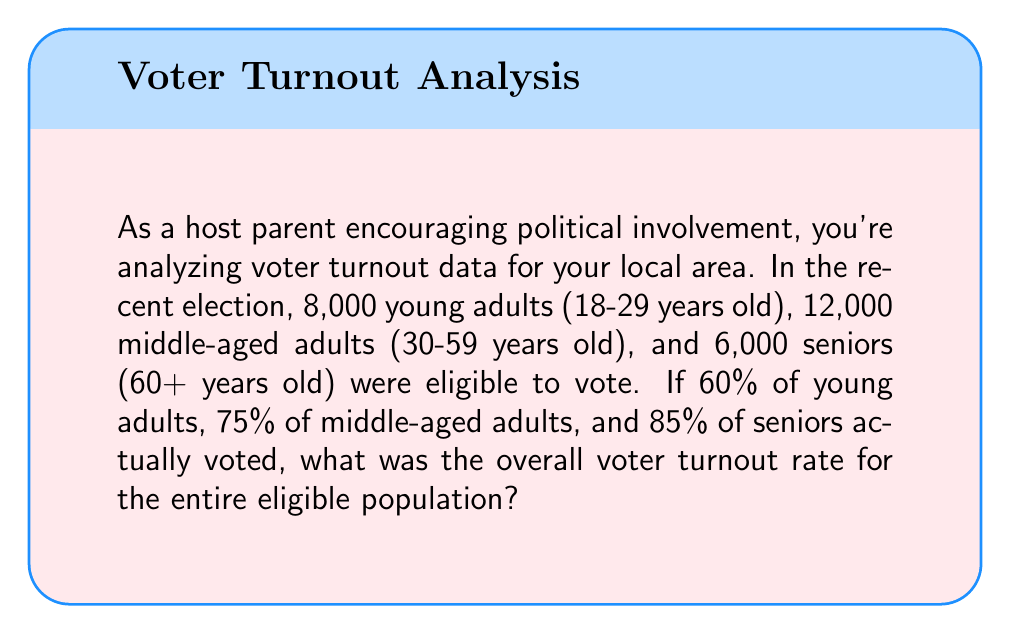Provide a solution to this math problem. Let's approach this step-by-step:

1) First, calculate the number of voters in each age group:

   Young adults: $8,000 \times 60\% = 8,000 \times 0.60 = 4,800$
   Middle-aged adults: $12,000 \times 75\% = 12,000 \times 0.75 = 9,000$
   Seniors: $6,000 \times 85\% = 6,000 \times 0.85 = 5,100$

2) Sum up the total number of voters:

   Total voters = $4,800 + 9,000 + 5,100 = 18,900$

3) Calculate the total eligible population:

   Total eligible = $8,000 + 12,000 + 6,000 = 26,000$

4) Calculate the overall turnout rate:

   Turnout rate = $\frac{\text{Total voters}}{\text{Total eligible}} \times 100\%$

   $= \frac{18,900}{26,000} \times 100\%$

   $= 0.7269230769... \times 100\%$

   $\approx 72.69\%$
Answer: $72.69\%$ 